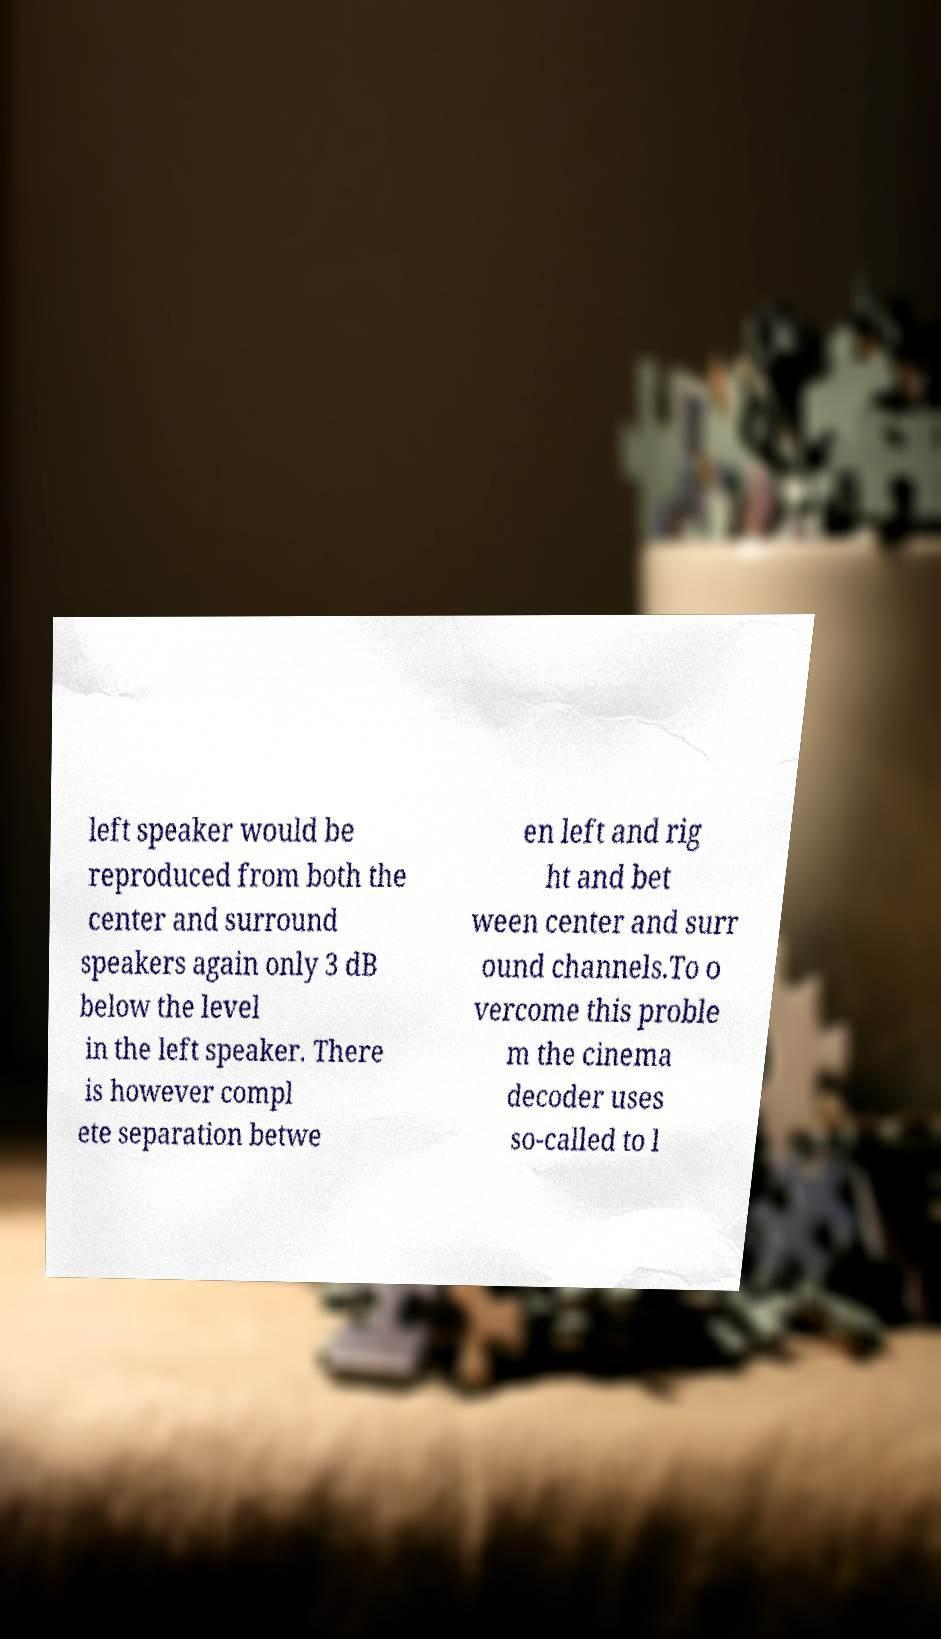Please read and relay the text visible in this image. What does it say? left speaker would be reproduced from both the center and surround speakers again only 3 dB below the level in the left speaker. There is however compl ete separation betwe en left and rig ht and bet ween center and surr ound channels.To o vercome this proble m the cinema decoder uses so-called to l 